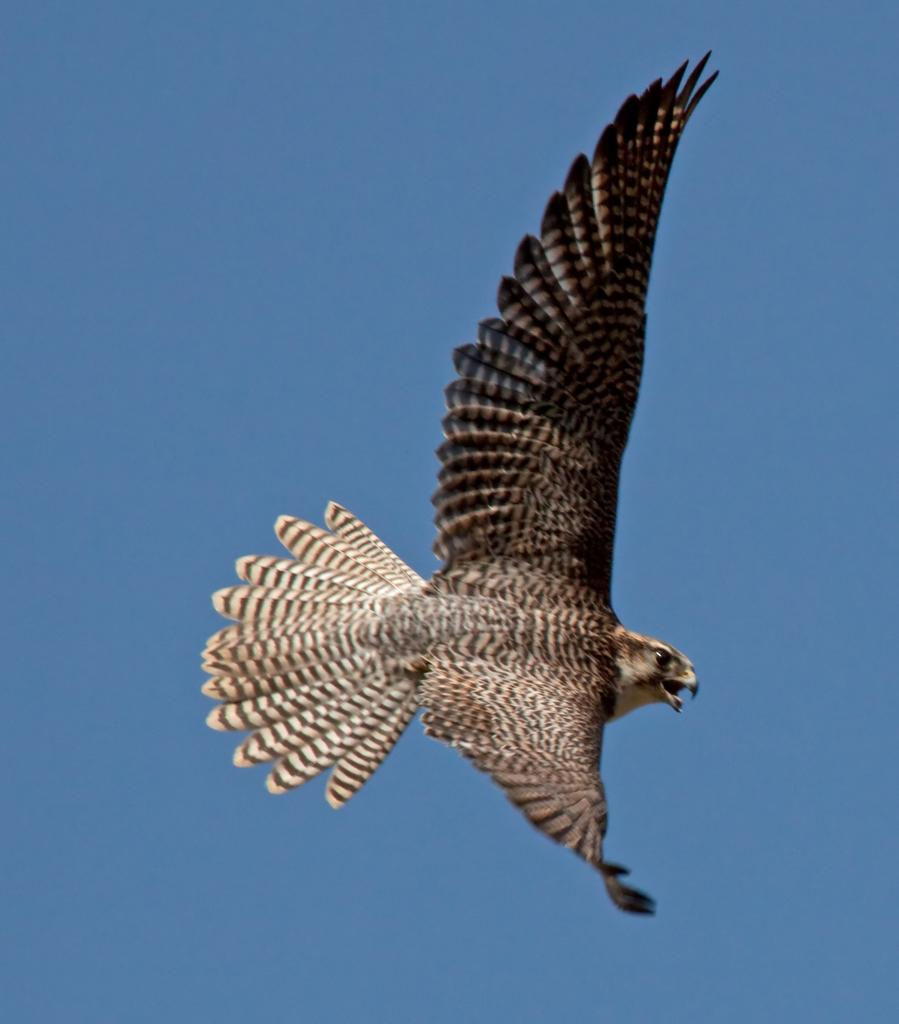What type of animal is in the image? There is an eagle in the image. What are the main features of the eagle? The eagle has eyes, wings, and a mouth. Where is the bedroom located in the image? There is no bedroom present in the image; it features an eagle. What type of boot is the eagle wearing in the image? There is no boot present in the image; it features an eagle without any footwear. 